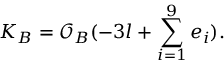<formula> <loc_0><loc_0><loc_500><loc_500>K _ { B } = { \mathcal { O } } _ { B } ( - 3 l + \sum _ { i = 1 } ^ { 9 } e _ { i } ) .</formula> 